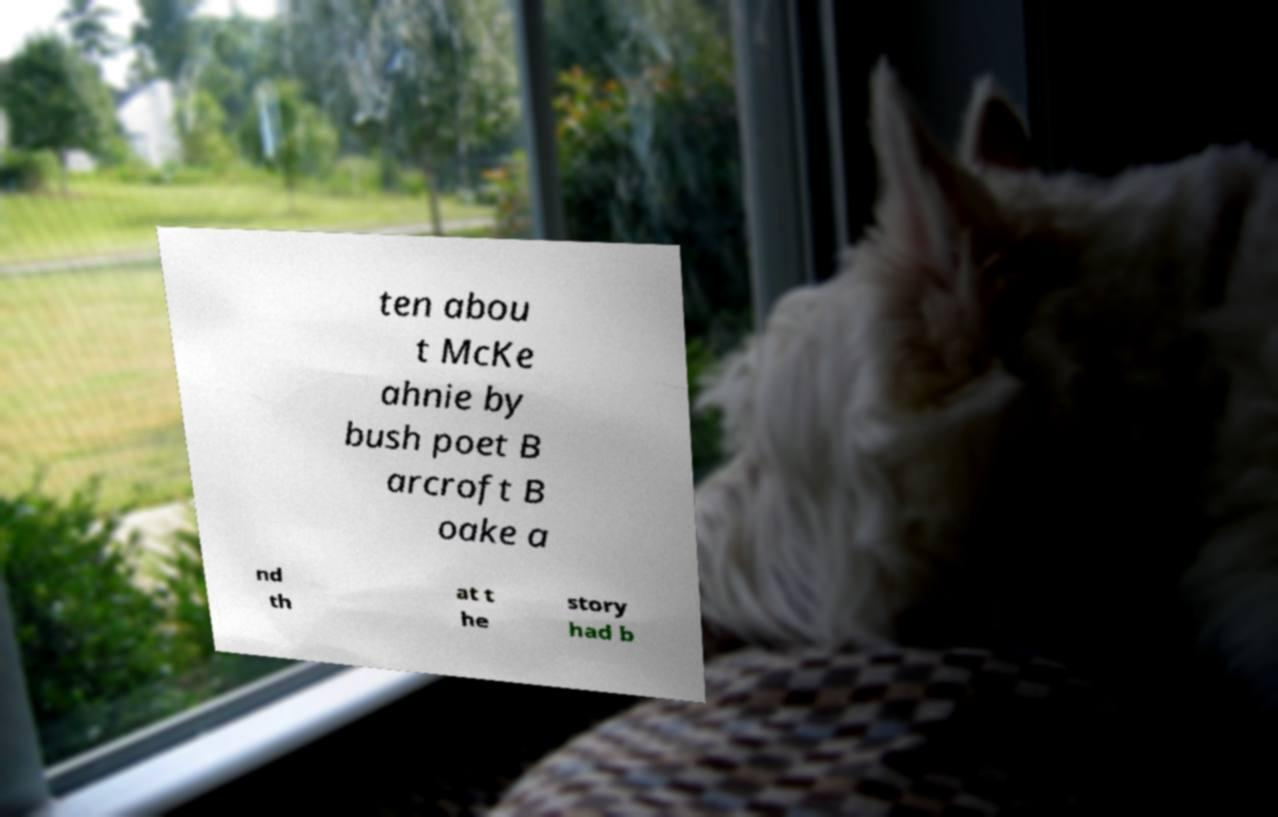For documentation purposes, I need the text within this image transcribed. Could you provide that? ten abou t McKe ahnie by bush poet B arcroft B oake a nd th at t he story had b 